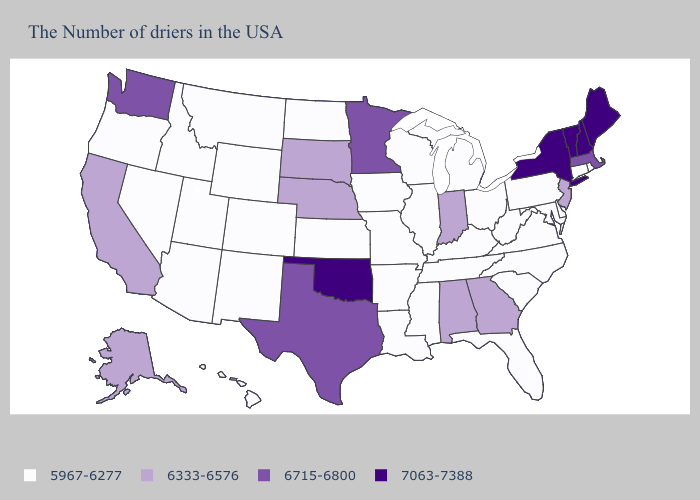Name the states that have a value in the range 6715-6800?
Concise answer only. Massachusetts, Minnesota, Texas, Washington. Does Nebraska have the lowest value in the MidWest?
Write a very short answer. No. What is the value of South Carolina?
Be succinct. 5967-6277. Does California have the highest value in the USA?
Be succinct. No. What is the value of Maryland?
Quick response, please. 5967-6277. Name the states that have a value in the range 7063-7388?
Answer briefly. Maine, New Hampshire, Vermont, New York, Oklahoma. Does Washington have the highest value in the West?
Write a very short answer. Yes. Does Wyoming have the lowest value in the USA?
Quick response, please. Yes. What is the value of Texas?
Answer briefly. 6715-6800. What is the value of Wisconsin?
Be succinct. 5967-6277. What is the value of Georgia?
Quick response, please. 6333-6576. Does the map have missing data?
Answer briefly. No. Which states hav the highest value in the West?
Quick response, please. Washington. Does Hawaii have a higher value than Illinois?
Be succinct. No. Name the states that have a value in the range 7063-7388?
Be succinct. Maine, New Hampshire, Vermont, New York, Oklahoma. 